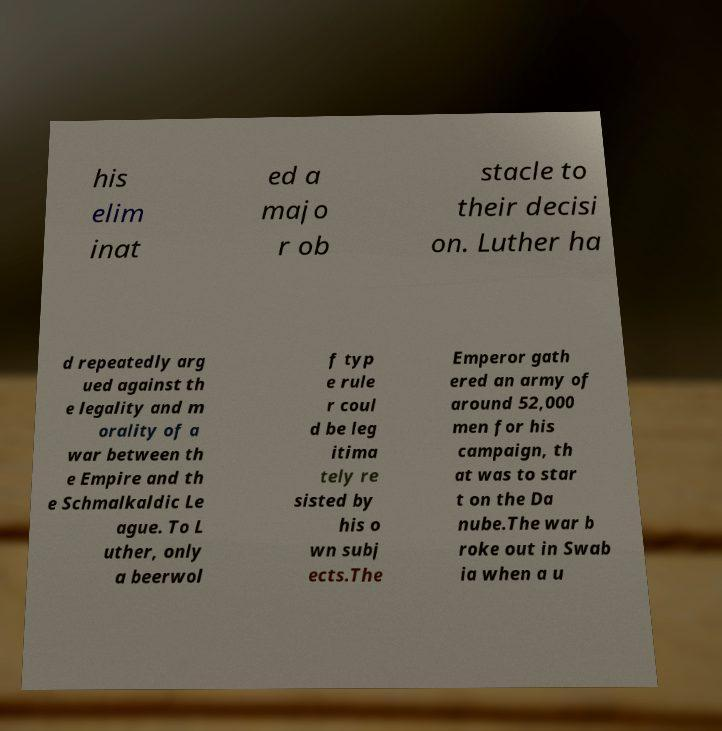Could you extract and type out the text from this image? his elim inat ed a majo r ob stacle to their decisi on. Luther ha d repeatedly arg ued against th e legality and m orality of a war between th e Empire and th e Schmalkaldic Le ague. To L uther, only a beerwol f typ e rule r coul d be leg itima tely re sisted by his o wn subj ects.The Emperor gath ered an army of around 52,000 men for his campaign, th at was to star t on the Da nube.The war b roke out in Swab ia when a u 